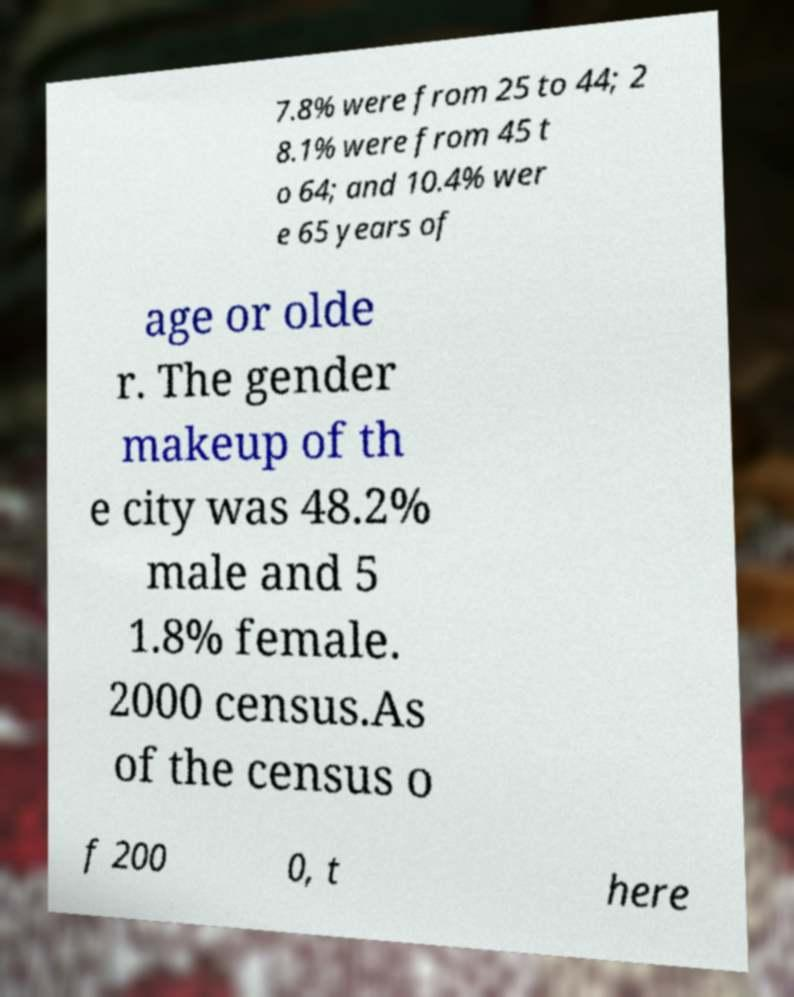Could you extract and type out the text from this image? 7.8% were from 25 to 44; 2 8.1% were from 45 t o 64; and 10.4% wer e 65 years of age or olde r. The gender makeup of th e city was 48.2% male and 5 1.8% female. 2000 census.As of the census o f 200 0, t here 